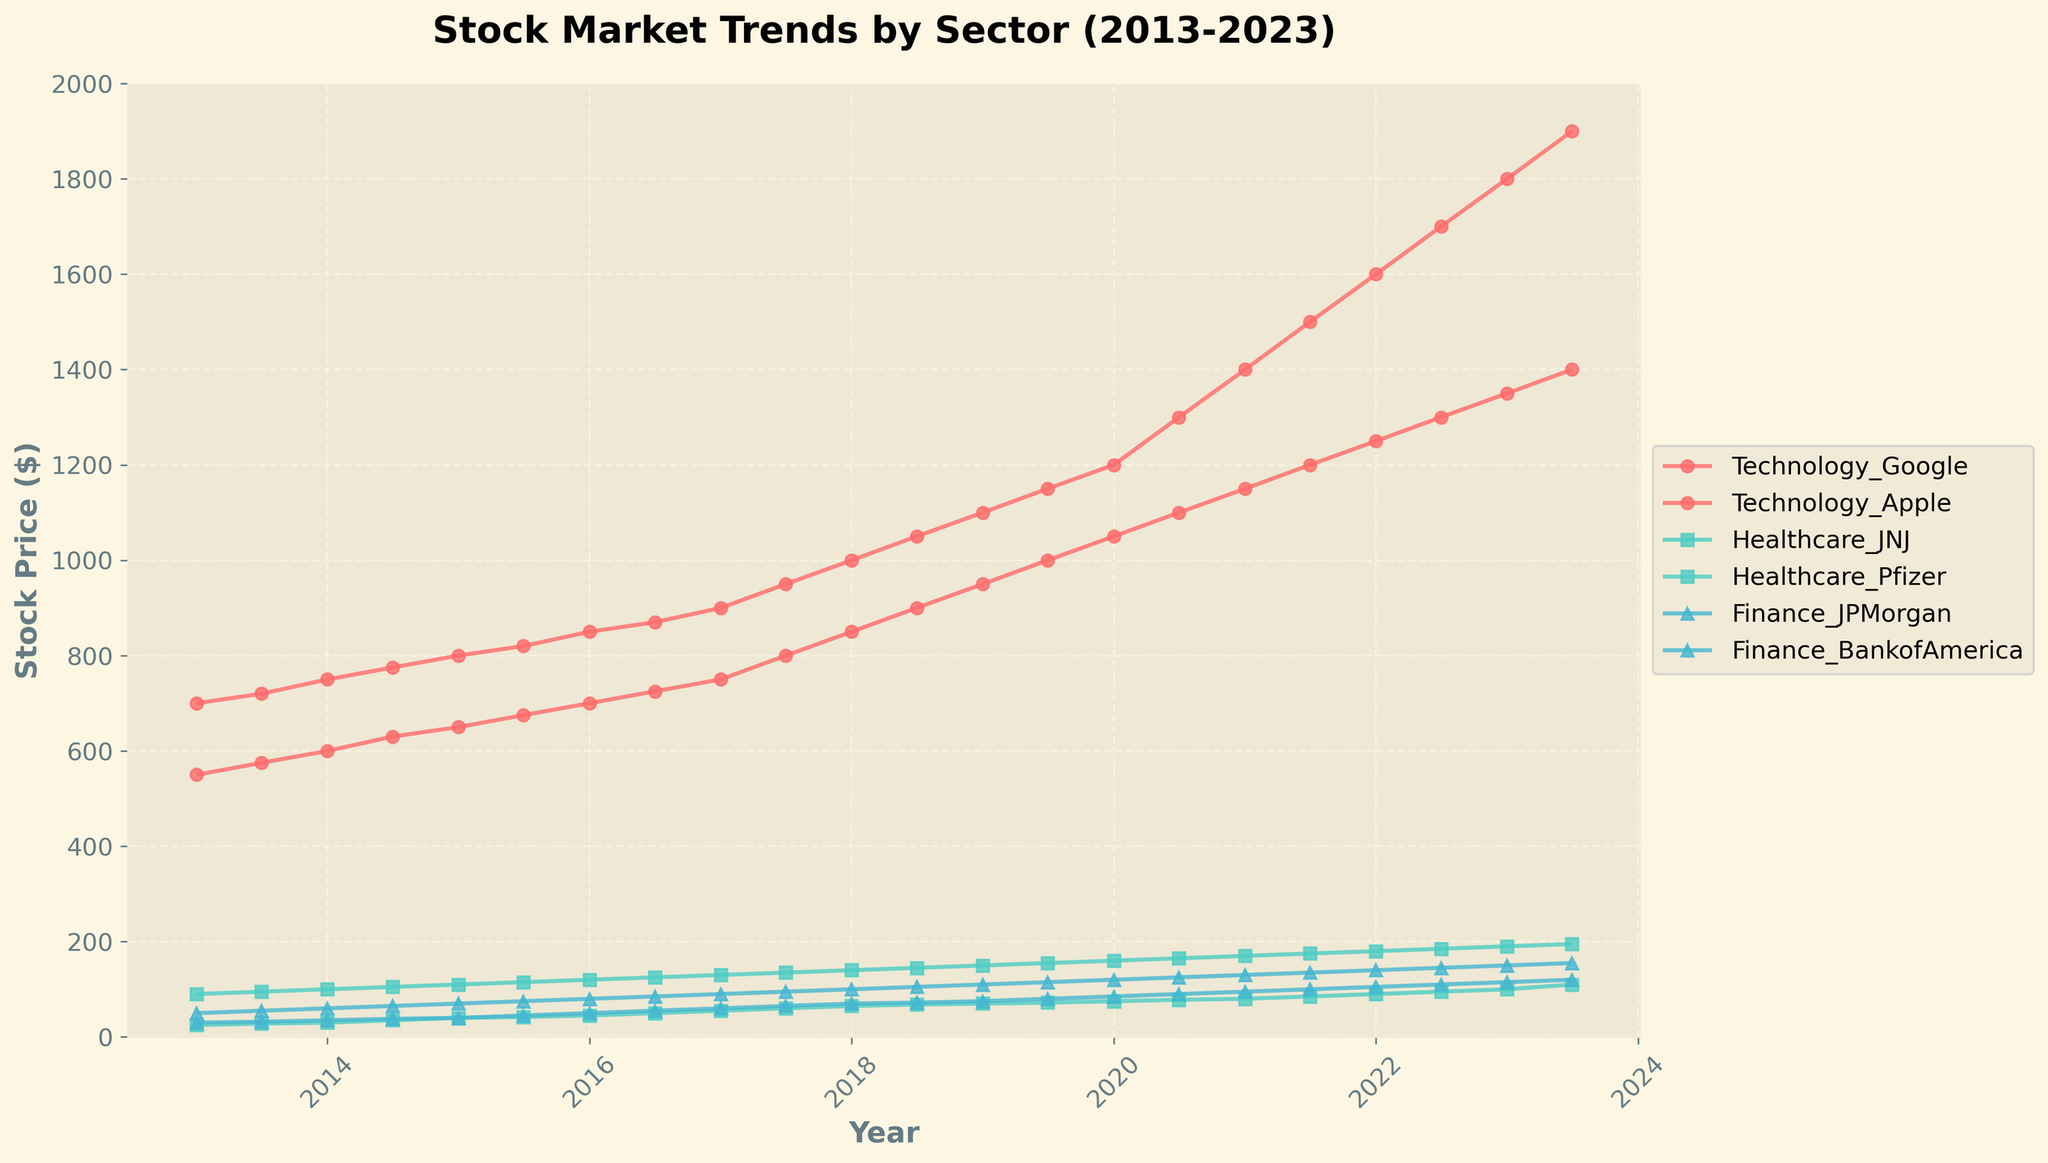What is the title of the figure? The title is typically located at the top of the figure. In this case, it reads "Stock Market Trends by Sector (2013-2023)".
Answer: Stock Market Trends by Sector (2013-2023) What are the sectors being compared in the plot? The legend on the right side indicates the sectors. They are Technology, Healthcare, and Finance.
Answer: Technology, Healthcare, Finance Which company has the highest stock price at the end of the period? Look at the final data points on the right side of the plot for each company. The highest stock price in 2023-07-01 is for Google in the Technology sector.
Answer: Google How does the performance of Pfizer compare to JNJ in 2020? Look at the data points for Pfizer and JNJ around the year 2020. Pfizer's stock price is lower than JNJ's price throughout the year.
Answer: Lower What is the trend for Apple's stock price between 2013 and 2023? Observe the line for Apple from start to end. Apple's stock price shows a continuous upward trend from 2013 to 2023.
Answer: Upward trend By how much did Google’s stock price increase from 2013 to 2023? Find the starting and ending points for Google and subtract the initial value from the final value. It increased from 700 to 1900, the difference is 1200 dollars.
Answer: 1200 dollars Which company had the most significant increase in stock price over the 10 years? Compare the overall increase in stock prices for all companies from 2013 to 2023. Google in the Technology sector had the most significant increase.
Answer: Google Are there any sectors that display similar trends? Compare the overall shape of the lines for each sector. The Finance sector companies (JPMorgan and Bank of America) exhibit fairly similar trends.
Answer: Finance sector (JPMorgan and Bank of America) How does the average stock price of Healthcare sector companies in 2023 compare to that of Technology sector companies in 2013? Calculate the average of JNJ and Pfizer in 2023 and compare it to the average of Google and Apple in 2013. In 2023, average Healthcare (195+110)/2 = 152.5; In 2013, average Technology (700+550)/2 = 625. Mean in 2013 is much higher.
Answer: Higher in 2013 What is the trend of Bank of America's stock price from 2013 to 2023? Look at the start and end points for Bank of America and the direction of the line in between. The stock price shows a continuous upward trend from 2013 to 2023.
Answer: Upward trend 